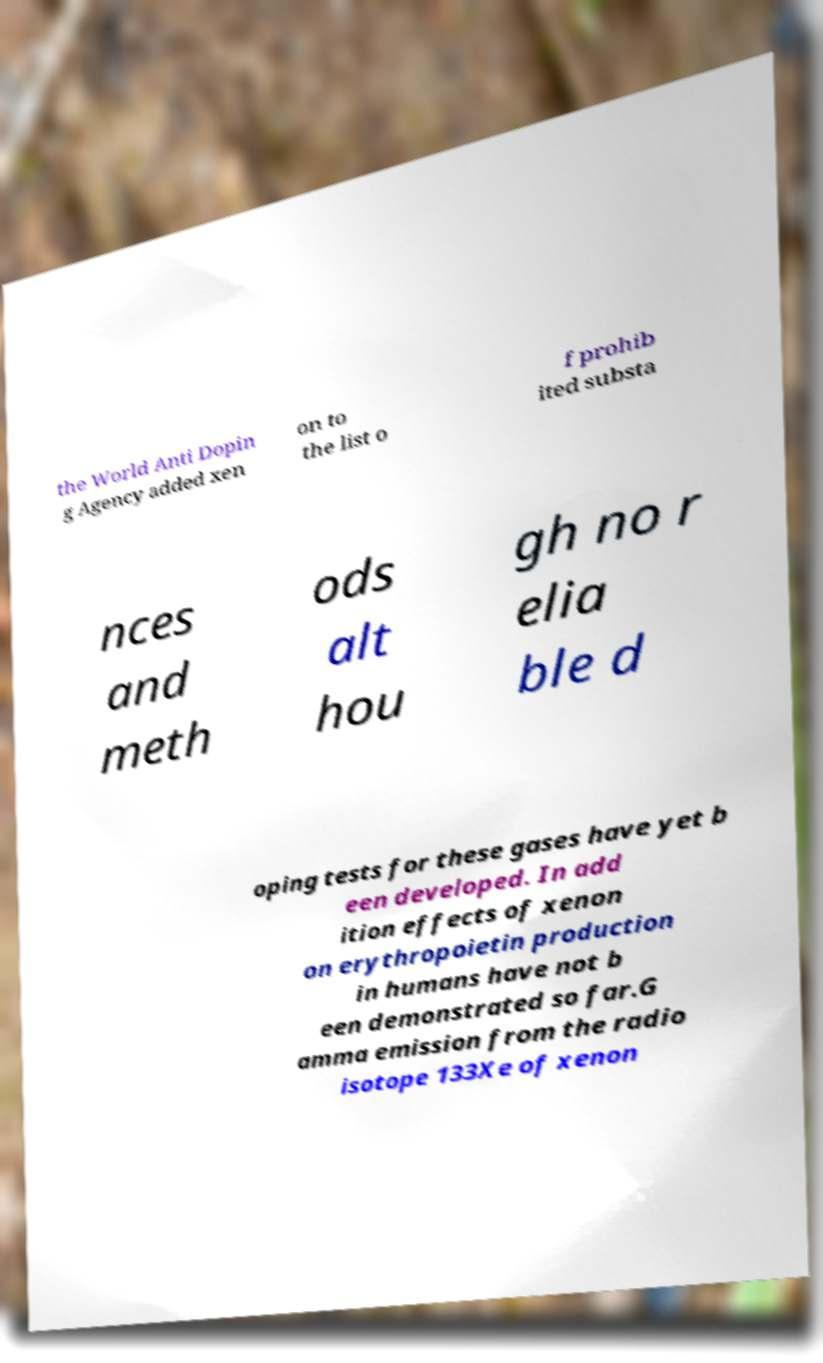For documentation purposes, I need the text within this image transcribed. Could you provide that? the World Anti Dopin g Agency added xen on to the list o f prohib ited substa nces and meth ods alt hou gh no r elia ble d oping tests for these gases have yet b een developed. In add ition effects of xenon on erythropoietin production in humans have not b een demonstrated so far.G amma emission from the radio isotope 133Xe of xenon 